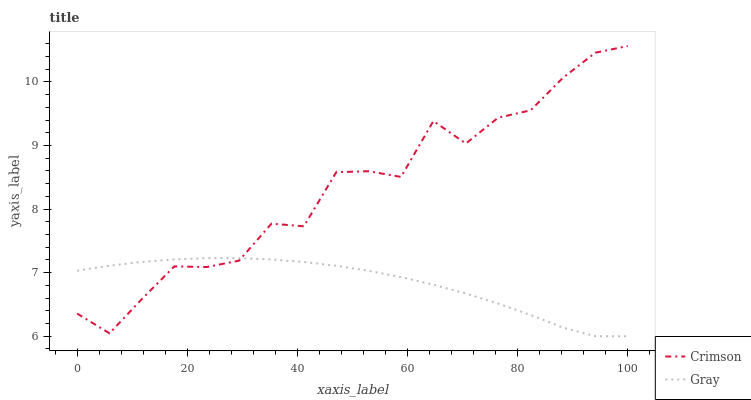Does Gray have the minimum area under the curve?
Answer yes or no. Yes. Does Crimson have the maximum area under the curve?
Answer yes or no. Yes. Does Gray have the maximum area under the curve?
Answer yes or no. No. Is Gray the smoothest?
Answer yes or no. Yes. Is Crimson the roughest?
Answer yes or no. Yes. Is Gray the roughest?
Answer yes or no. No. Does Gray have the lowest value?
Answer yes or no. Yes. Does Crimson have the highest value?
Answer yes or no. Yes. Does Gray have the highest value?
Answer yes or no. No. Does Gray intersect Crimson?
Answer yes or no. Yes. Is Gray less than Crimson?
Answer yes or no. No. Is Gray greater than Crimson?
Answer yes or no. No. 